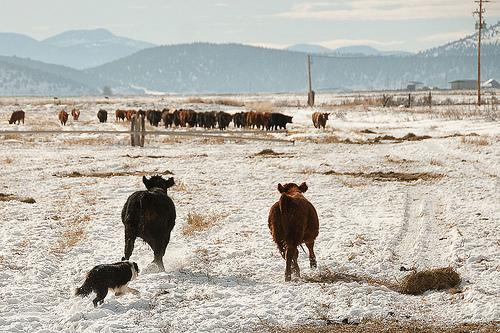How many objects are there in the image that involve clouds? There are 22 objects in the image that involve clouds. Identify the main elements present in the image and relate them to each other. The image shows a herd of cows, with a brown cow running, dogs behind them, white clouds in the blue sky above, a distant mountain range, and distant buildings in the background. Mention a possible interaction between the animals in the image. A dog is running behind the cows, which could mean that it is herding them or playing. What are the two distant objects mentioned in the image? The two distant objects mentioned are a distant mountain range and distant buildings. Estimate the number of total objects present in the image. There are approximately 43 objects present in the image, including cows, dogs, clouds, buildings, and pasture. What is the weather like in the image, based on the description provided? The weather seems to be clear and sunny, with white clouds scattered in the blue sky. Provide a brief description of the scene in the image. The image depicts white clouds in a blue sky, a herd of cows including black, brown, and brown and white ones, a black dog and a black and white cattle dog, as well as some distant buildings and a mountain range. In the context of the image, what is the significance of the snow-covered pasture? The snow-covered pasture shows the cold weather setting and could explain the presence of a black cow in the snow. Enumerate the animals visible in the image and their colors. There are 8 cows (6 brown, 1 black, and 1 brown and white) and 3 dogs (1 black, 1 white, and 1 black and white). Describe the overall sentiment portrayed by the image. The overall sentiment of the image is peaceful and serene, depicting a typical rural scene with animals and a beautiful sky. 